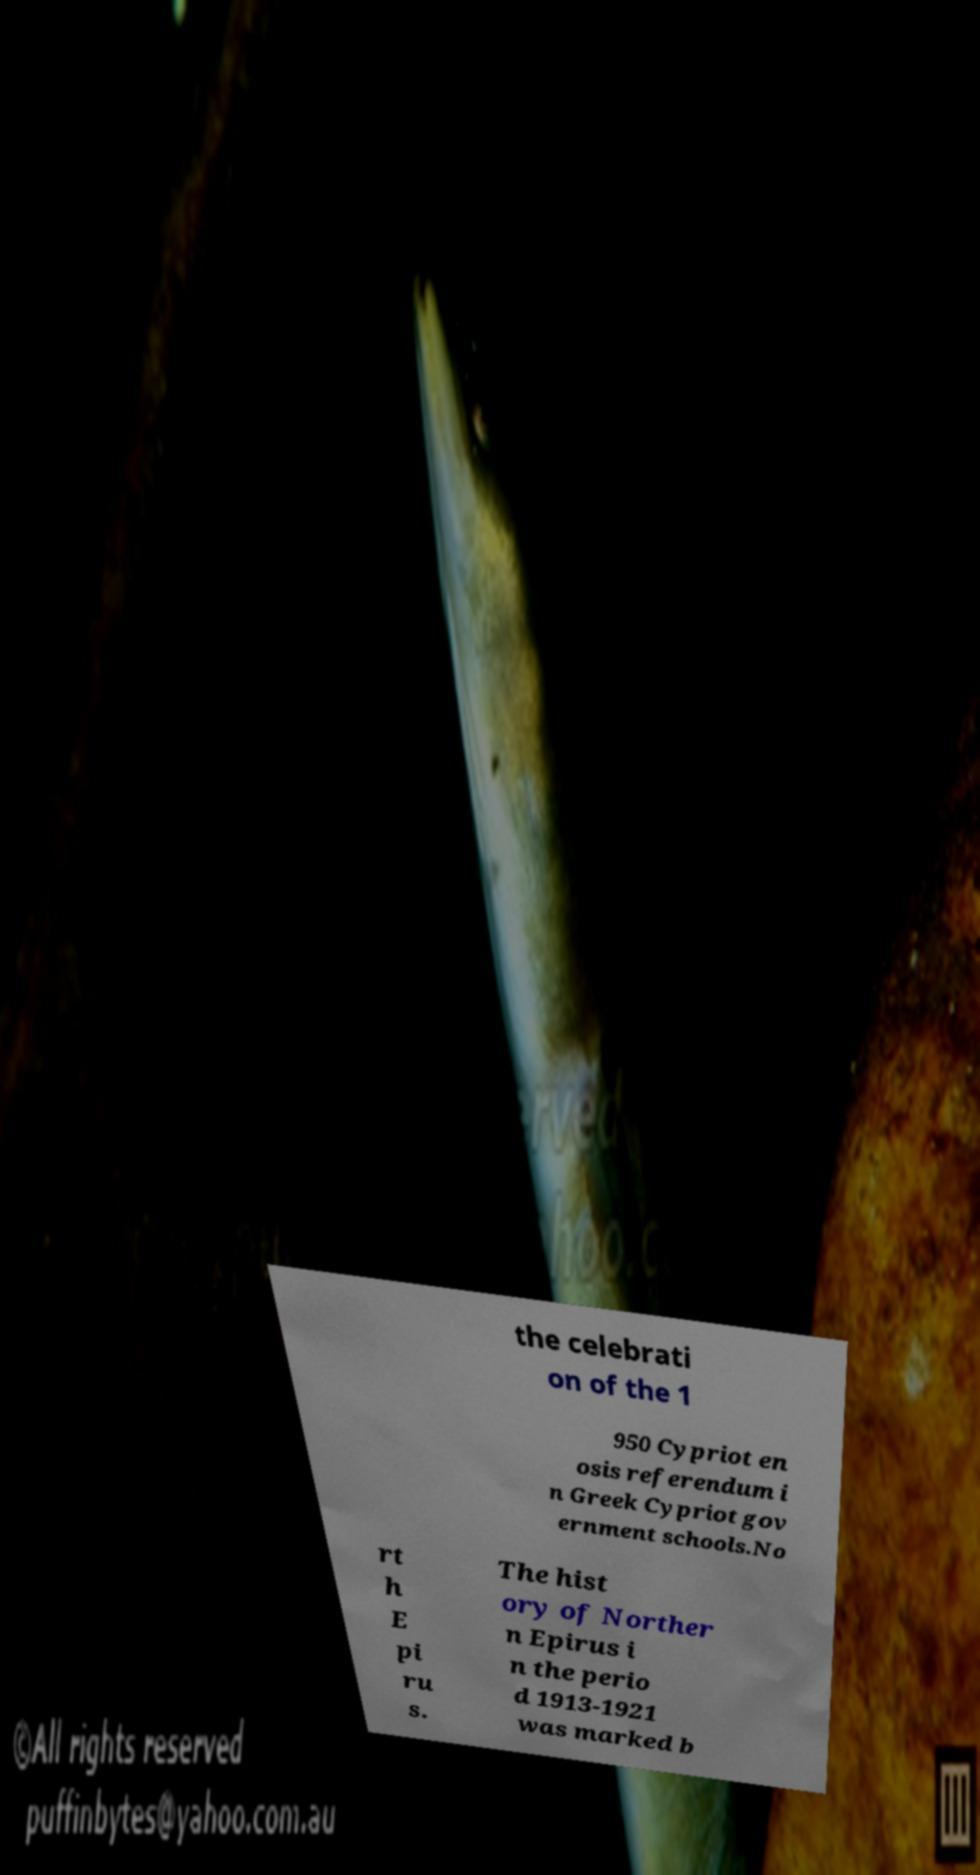Please read and relay the text visible in this image. What does it say? the celebrati on of the 1 950 Cypriot en osis referendum i n Greek Cypriot gov ernment schools.No rt h E pi ru s. The hist ory of Norther n Epirus i n the perio d 1913-1921 was marked b 